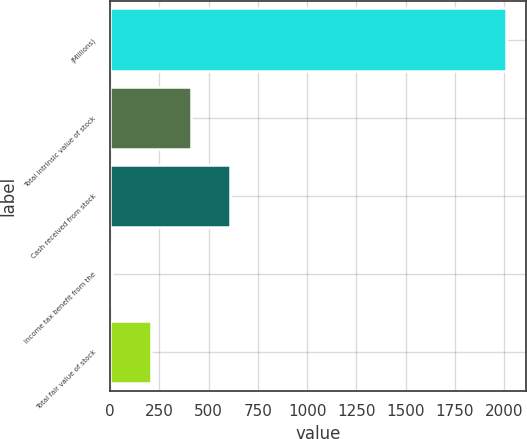Convert chart to OTSL. <chart><loc_0><loc_0><loc_500><loc_500><bar_chart><fcel>(Millions)<fcel>Total intrinsic value of stock<fcel>Cash received from stock<fcel>Income tax benefit from the<fcel>Total fair value of stock<nl><fcel>2011<fcel>409.4<fcel>609.6<fcel>9<fcel>209.2<nl></chart> 